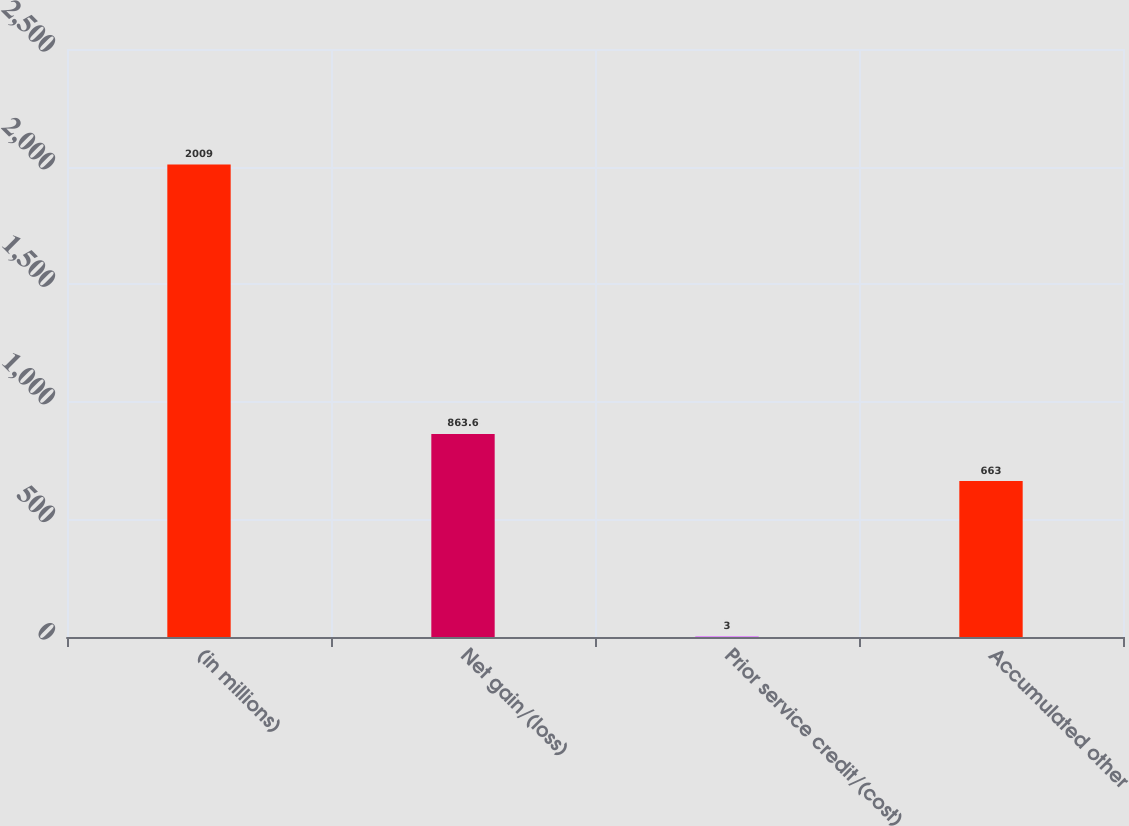Convert chart to OTSL. <chart><loc_0><loc_0><loc_500><loc_500><bar_chart><fcel>(in millions)<fcel>Net gain/(loss)<fcel>Prior service credit/(cost)<fcel>Accumulated other<nl><fcel>2009<fcel>863.6<fcel>3<fcel>663<nl></chart> 